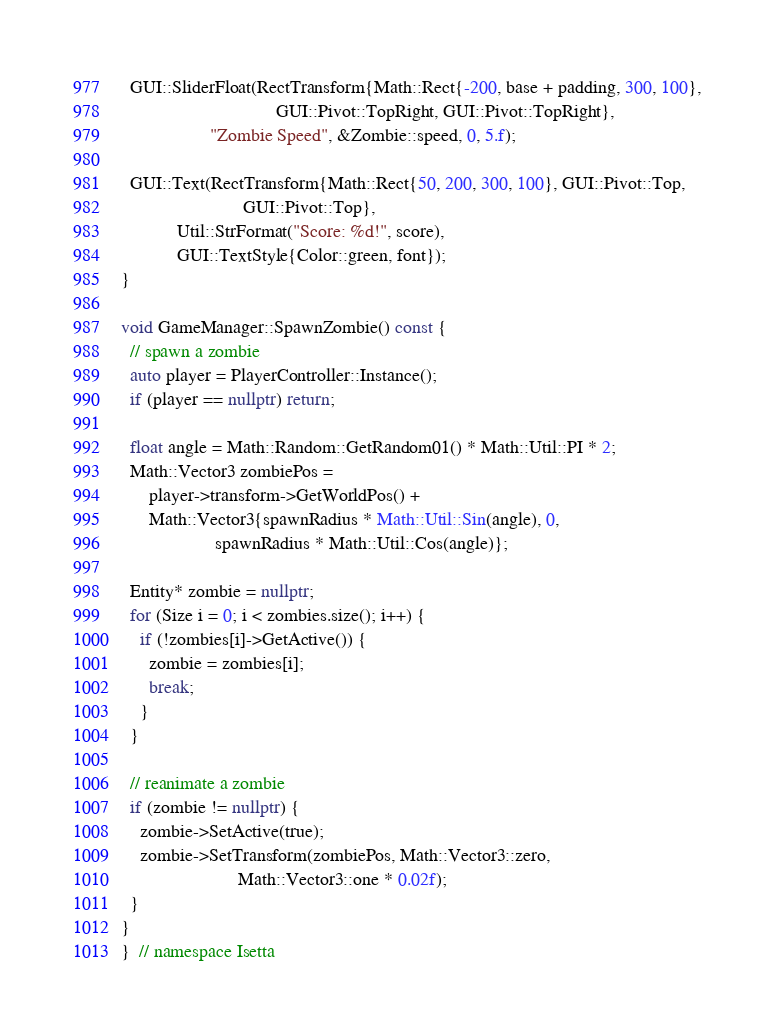<code> <loc_0><loc_0><loc_500><loc_500><_C++_>
  GUI::SliderFloat(RectTransform{Math::Rect{-200, base + padding, 300, 100},
                                 GUI::Pivot::TopRight, GUI::Pivot::TopRight},
                   "Zombie Speed", &Zombie::speed, 0, 5.f);

  GUI::Text(RectTransform{Math::Rect{50, 200, 300, 100}, GUI::Pivot::Top,
                          GUI::Pivot::Top},
            Util::StrFormat("Score: %d!", score),
            GUI::TextStyle{Color::green, font});
}

void GameManager::SpawnZombie() const {
  // spawn a zombie
  auto player = PlayerController::Instance();
  if (player == nullptr) return;

  float angle = Math::Random::GetRandom01() * Math::Util::PI * 2;
  Math::Vector3 zombiePos =
      player->transform->GetWorldPos() +
      Math::Vector3{spawnRadius * Math::Util::Sin(angle), 0,
                    spawnRadius * Math::Util::Cos(angle)};

  Entity* zombie = nullptr;
  for (Size i = 0; i < zombies.size(); i++) {
    if (!zombies[i]->GetActive()) {
      zombie = zombies[i];
      break;
    }
  }

  // reanimate a zombie
  if (zombie != nullptr) {
    zombie->SetActive(true);
    zombie->SetTransform(zombiePos, Math::Vector3::zero,
                         Math::Vector3::one * 0.02f);
  }
}
}  // namespace Isetta
</code> 